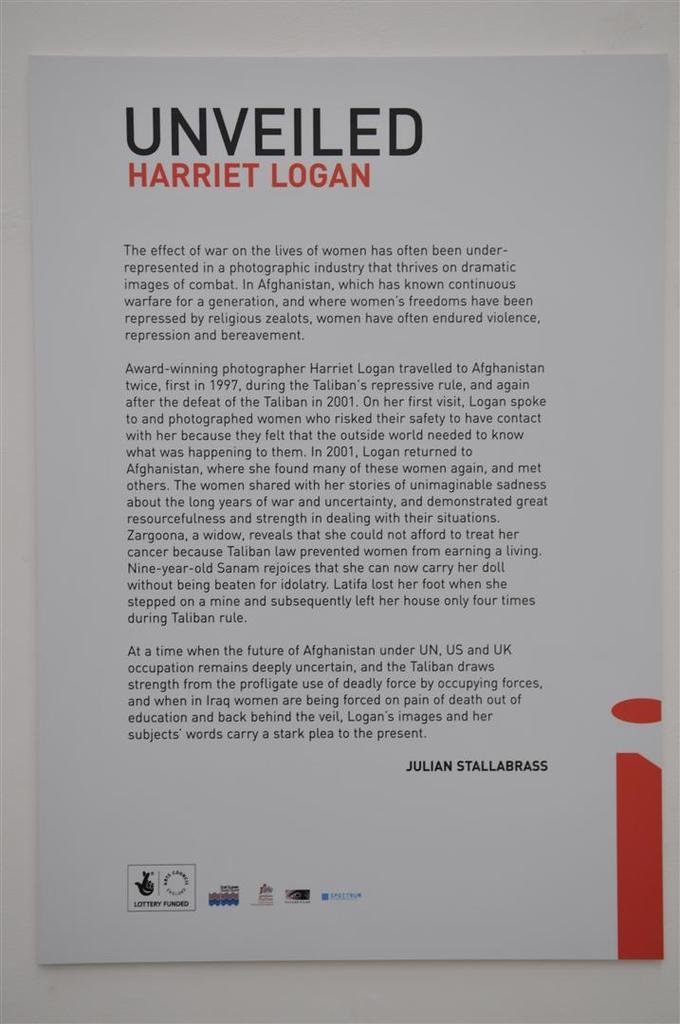<image>
Provide a brief description of the given image. Pamphlet book that says Unveiled Harriet Logan and Julian Stallabrass at the bottom. 